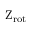Convert formula to latex. <formula><loc_0><loc_0><loc_500><loc_500>{ Z _ { r o t } }</formula> 